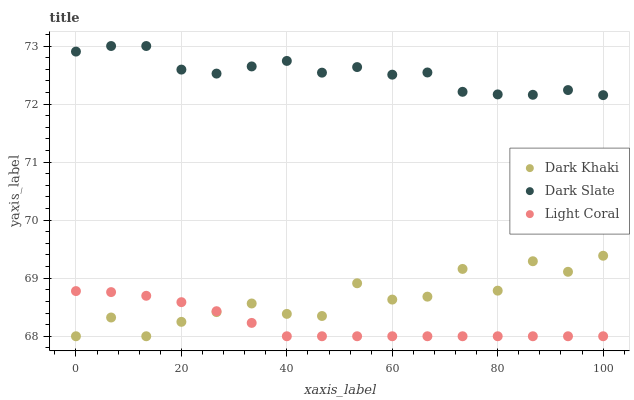Does Light Coral have the minimum area under the curve?
Answer yes or no. Yes. Does Dark Slate have the maximum area under the curve?
Answer yes or no. Yes. Does Dark Slate have the minimum area under the curve?
Answer yes or no. No. Does Light Coral have the maximum area under the curve?
Answer yes or no. No. Is Light Coral the smoothest?
Answer yes or no. Yes. Is Dark Khaki the roughest?
Answer yes or no. Yes. Is Dark Slate the smoothest?
Answer yes or no. No. Is Dark Slate the roughest?
Answer yes or no. No. Does Dark Khaki have the lowest value?
Answer yes or no. Yes. Does Dark Slate have the lowest value?
Answer yes or no. No. Does Dark Slate have the highest value?
Answer yes or no. Yes. Does Light Coral have the highest value?
Answer yes or no. No. Is Dark Khaki less than Dark Slate?
Answer yes or no. Yes. Is Dark Slate greater than Light Coral?
Answer yes or no. Yes. Does Light Coral intersect Dark Khaki?
Answer yes or no. Yes. Is Light Coral less than Dark Khaki?
Answer yes or no. No. Is Light Coral greater than Dark Khaki?
Answer yes or no. No. Does Dark Khaki intersect Dark Slate?
Answer yes or no. No. 